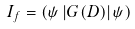<formula> <loc_0><loc_0><loc_500><loc_500>I _ { f } = \left ( \psi \left | G ( D ) \right | \psi \right )</formula> 